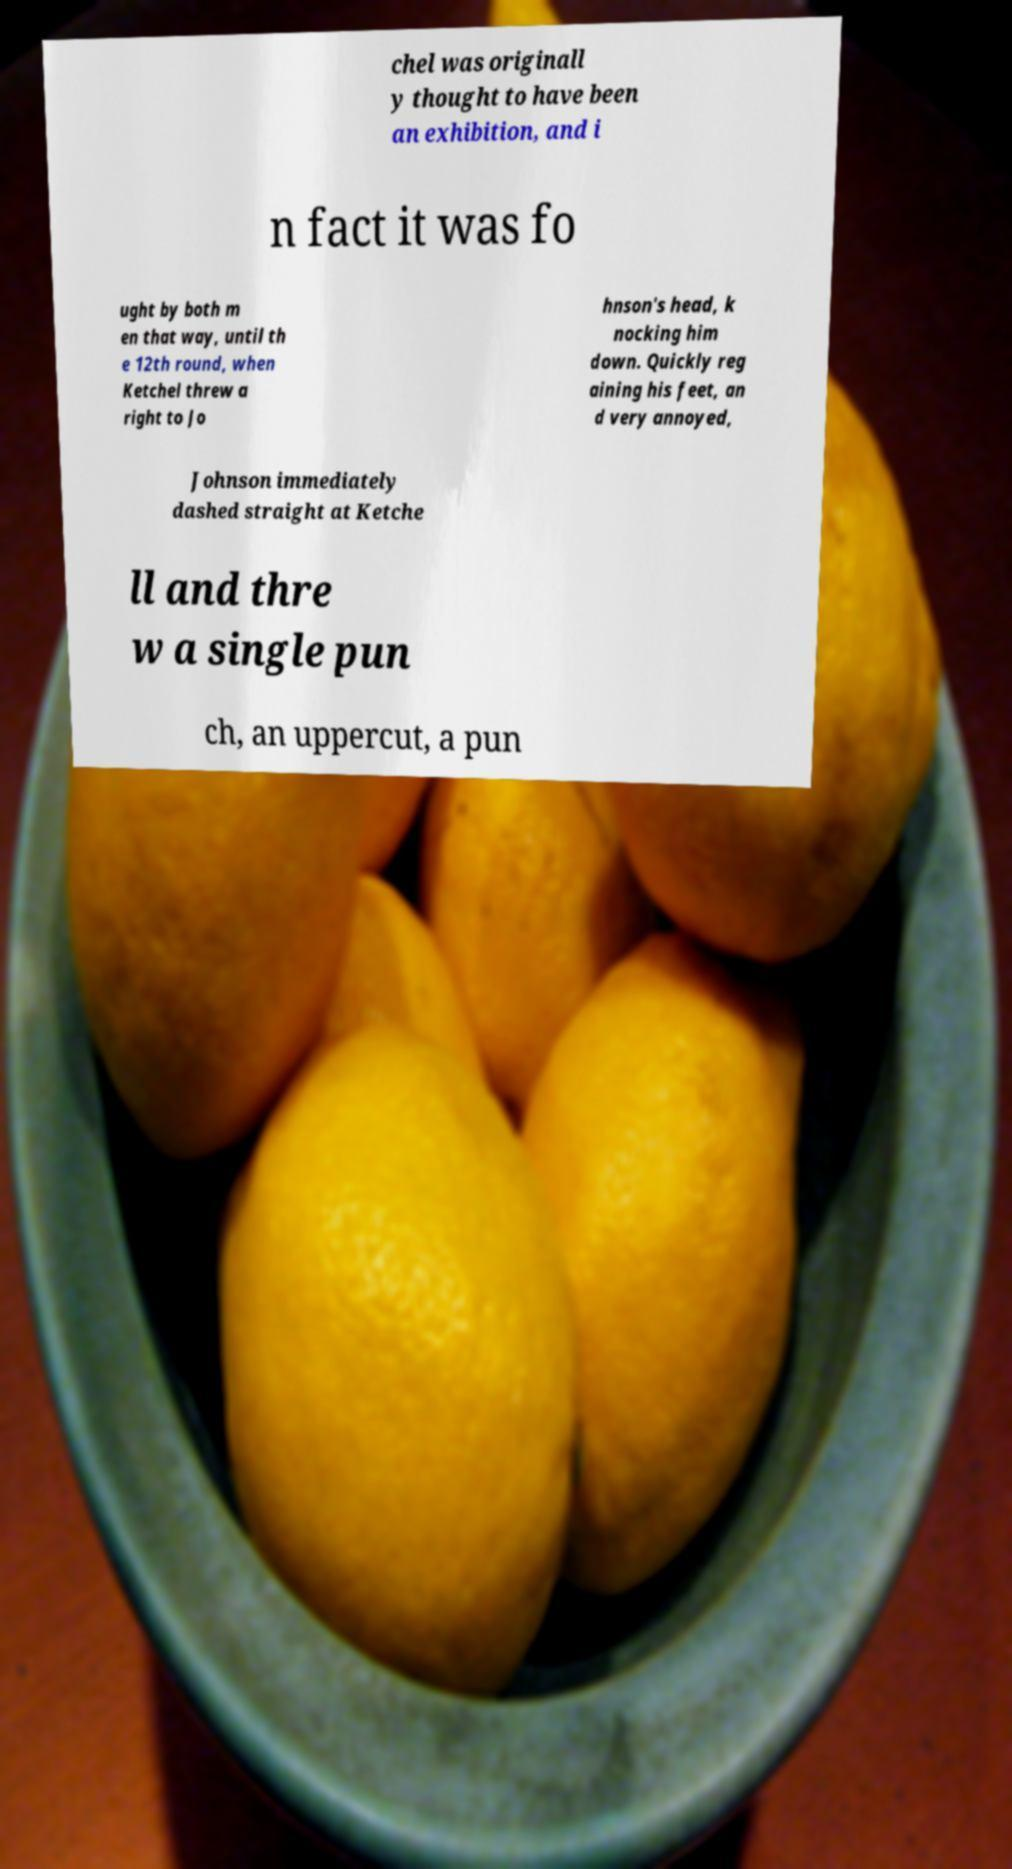I need the written content from this picture converted into text. Can you do that? chel was originall y thought to have been an exhibition, and i n fact it was fo ught by both m en that way, until th e 12th round, when Ketchel threw a right to Jo hnson's head, k nocking him down. Quickly reg aining his feet, an d very annoyed, Johnson immediately dashed straight at Ketche ll and thre w a single pun ch, an uppercut, a pun 